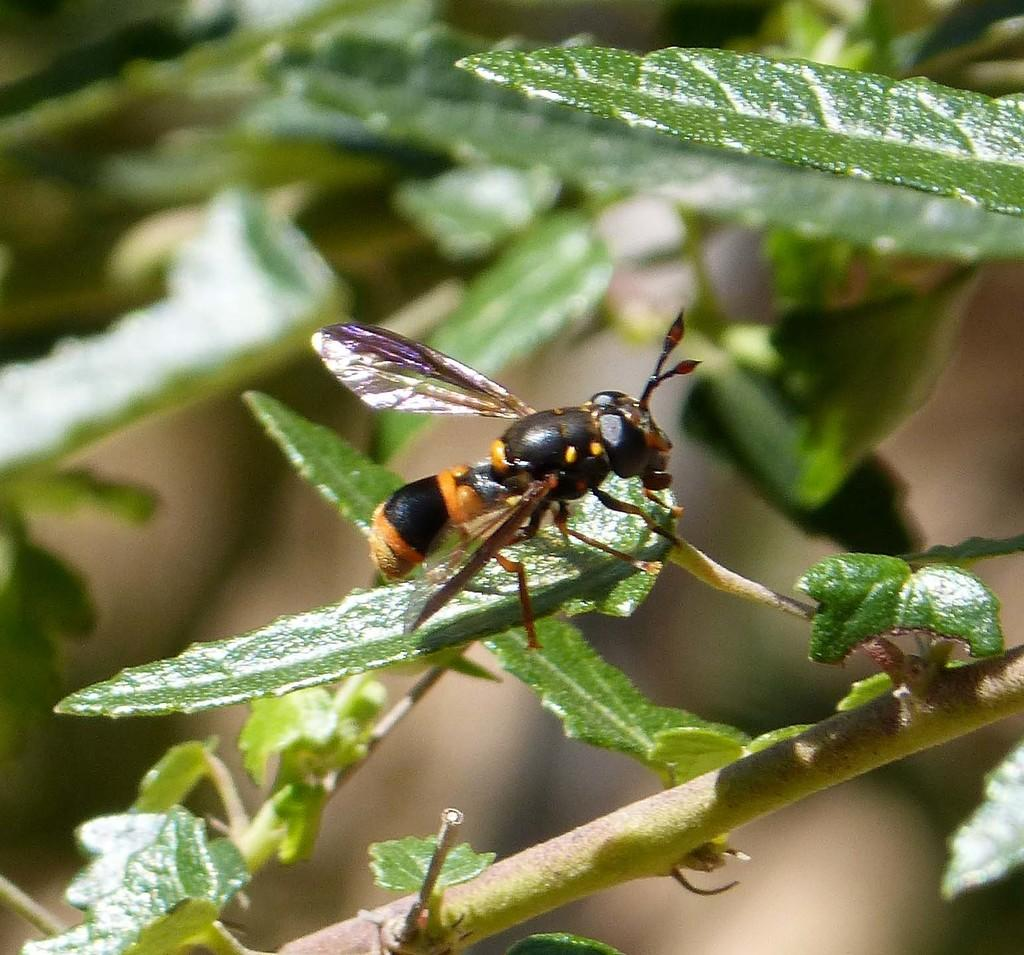What type of creature is in the image? There is an insect in the image. What is the insect doing in the image? The insect is laying on a leaf. What is the leaf attached to in the image? The leaf is part of a branch. How is the background of the insect depicted in the image? The background of the insect is blurred. Is the insect driving a car in the image? No, the insect is not driving a car in the image. The image features an insect laying on a leaf, and there is no car or driving activity depicted. 